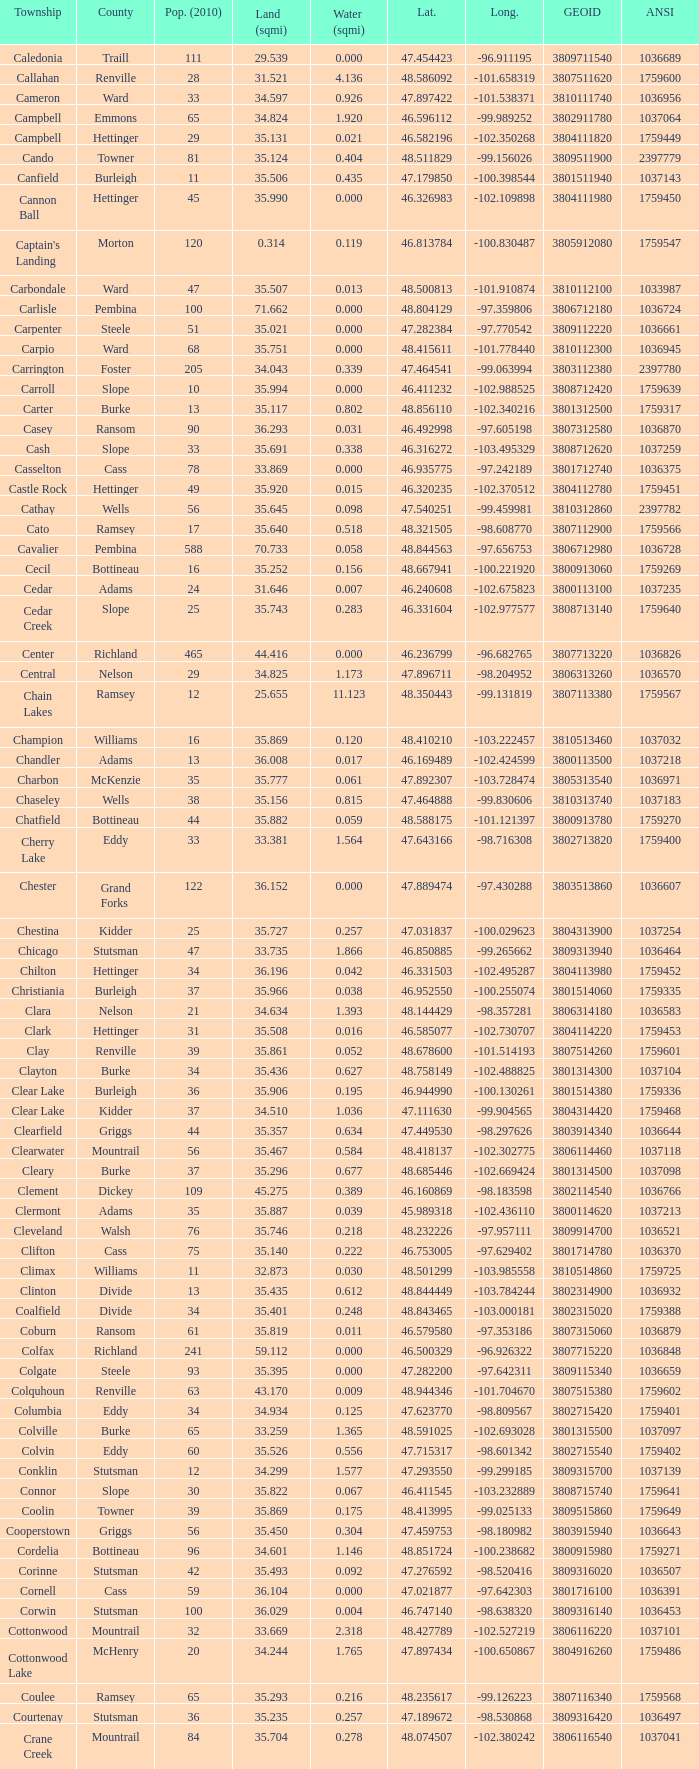What was the land area in sqmi that has a latitude of 48.763937? 35.898. 